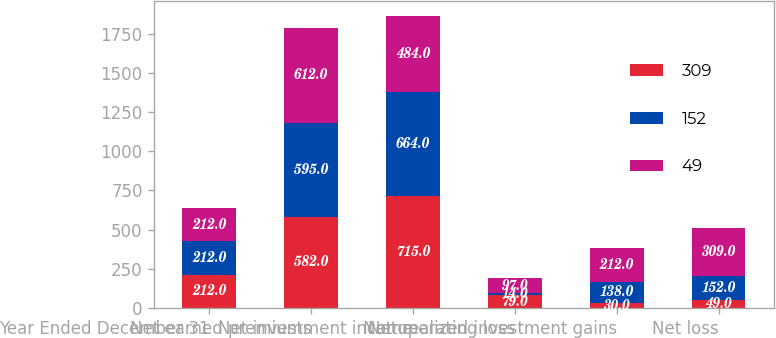Convert chart to OTSL. <chart><loc_0><loc_0><loc_500><loc_500><stacked_bar_chart><ecel><fcel>Year Ended December 31<fcel>Net earned premiums<fcel>Net investment income<fcel>Net operating loss<fcel>Net realized investment gains<fcel>Net loss<nl><fcel>309<fcel>212<fcel>582<fcel>715<fcel>79<fcel>30<fcel>49<nl><fcel>152<fcel>212<fcel>595<fcel>664<fcel>14<fcel>138<fcel>152<nl><fcel>49<fcel>212<fcel>612<fcel>484<fcel>97<fcel>212<fcel>309<nl></chart> 